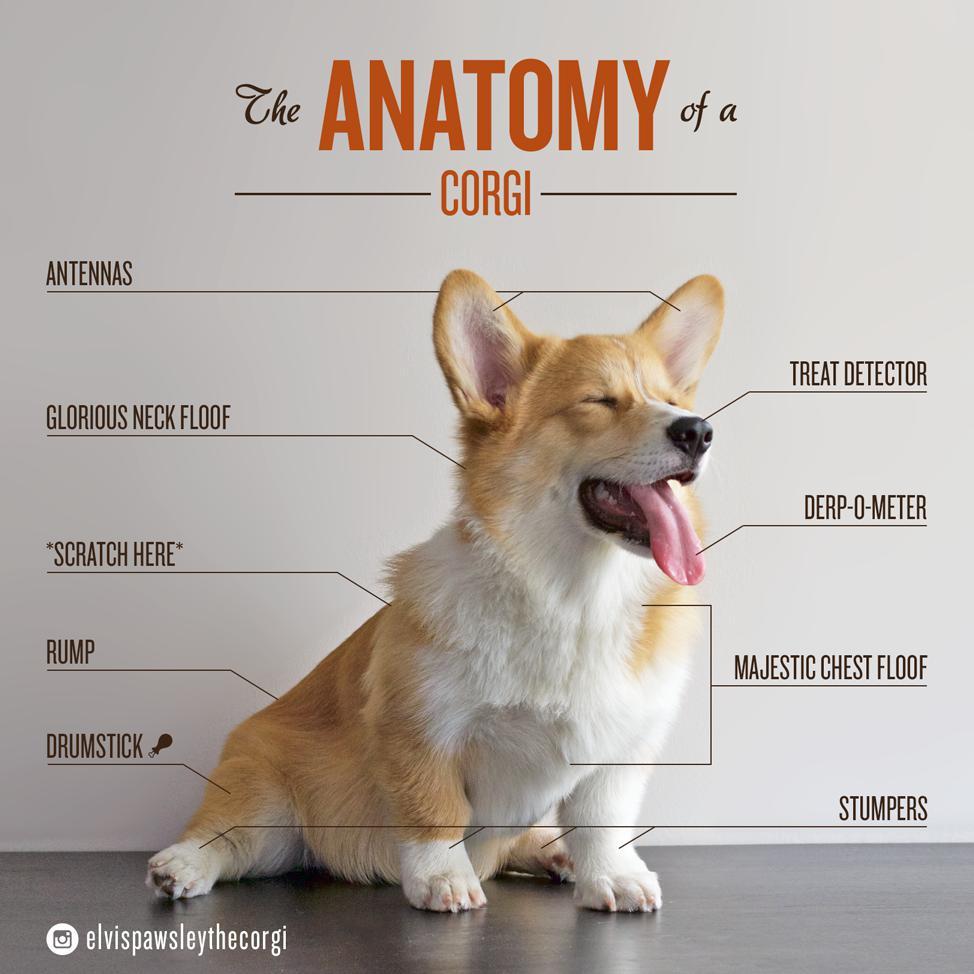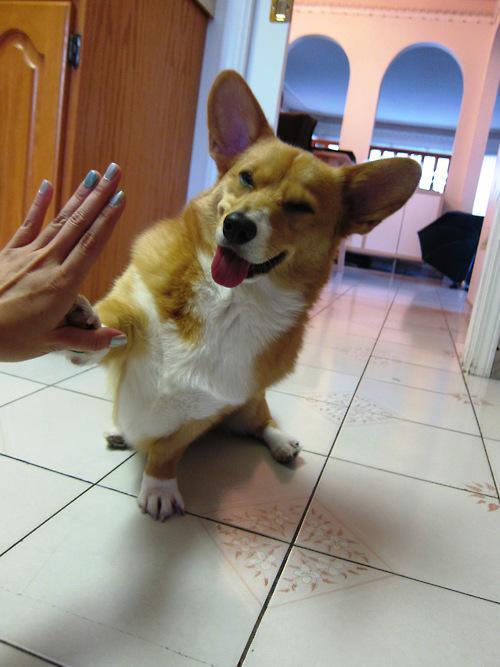The first image is the image on the left, the second image is the image on the right. For the images displayed, is the sentence "There is 1 or more corgi's showing it's tongue." factually correct? Answer yes or no. Yes. 